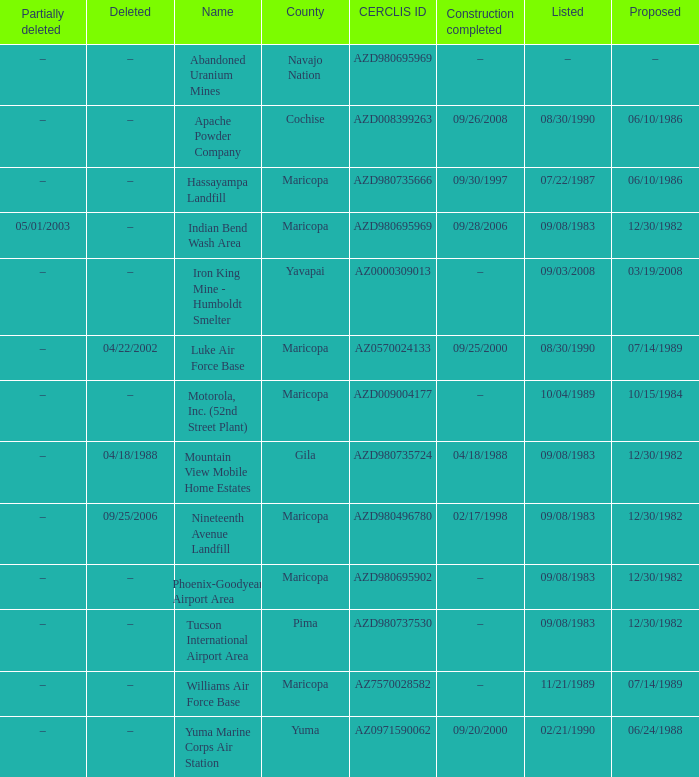When was the site partially deleted when the cerclis id is az7570028582? –. 